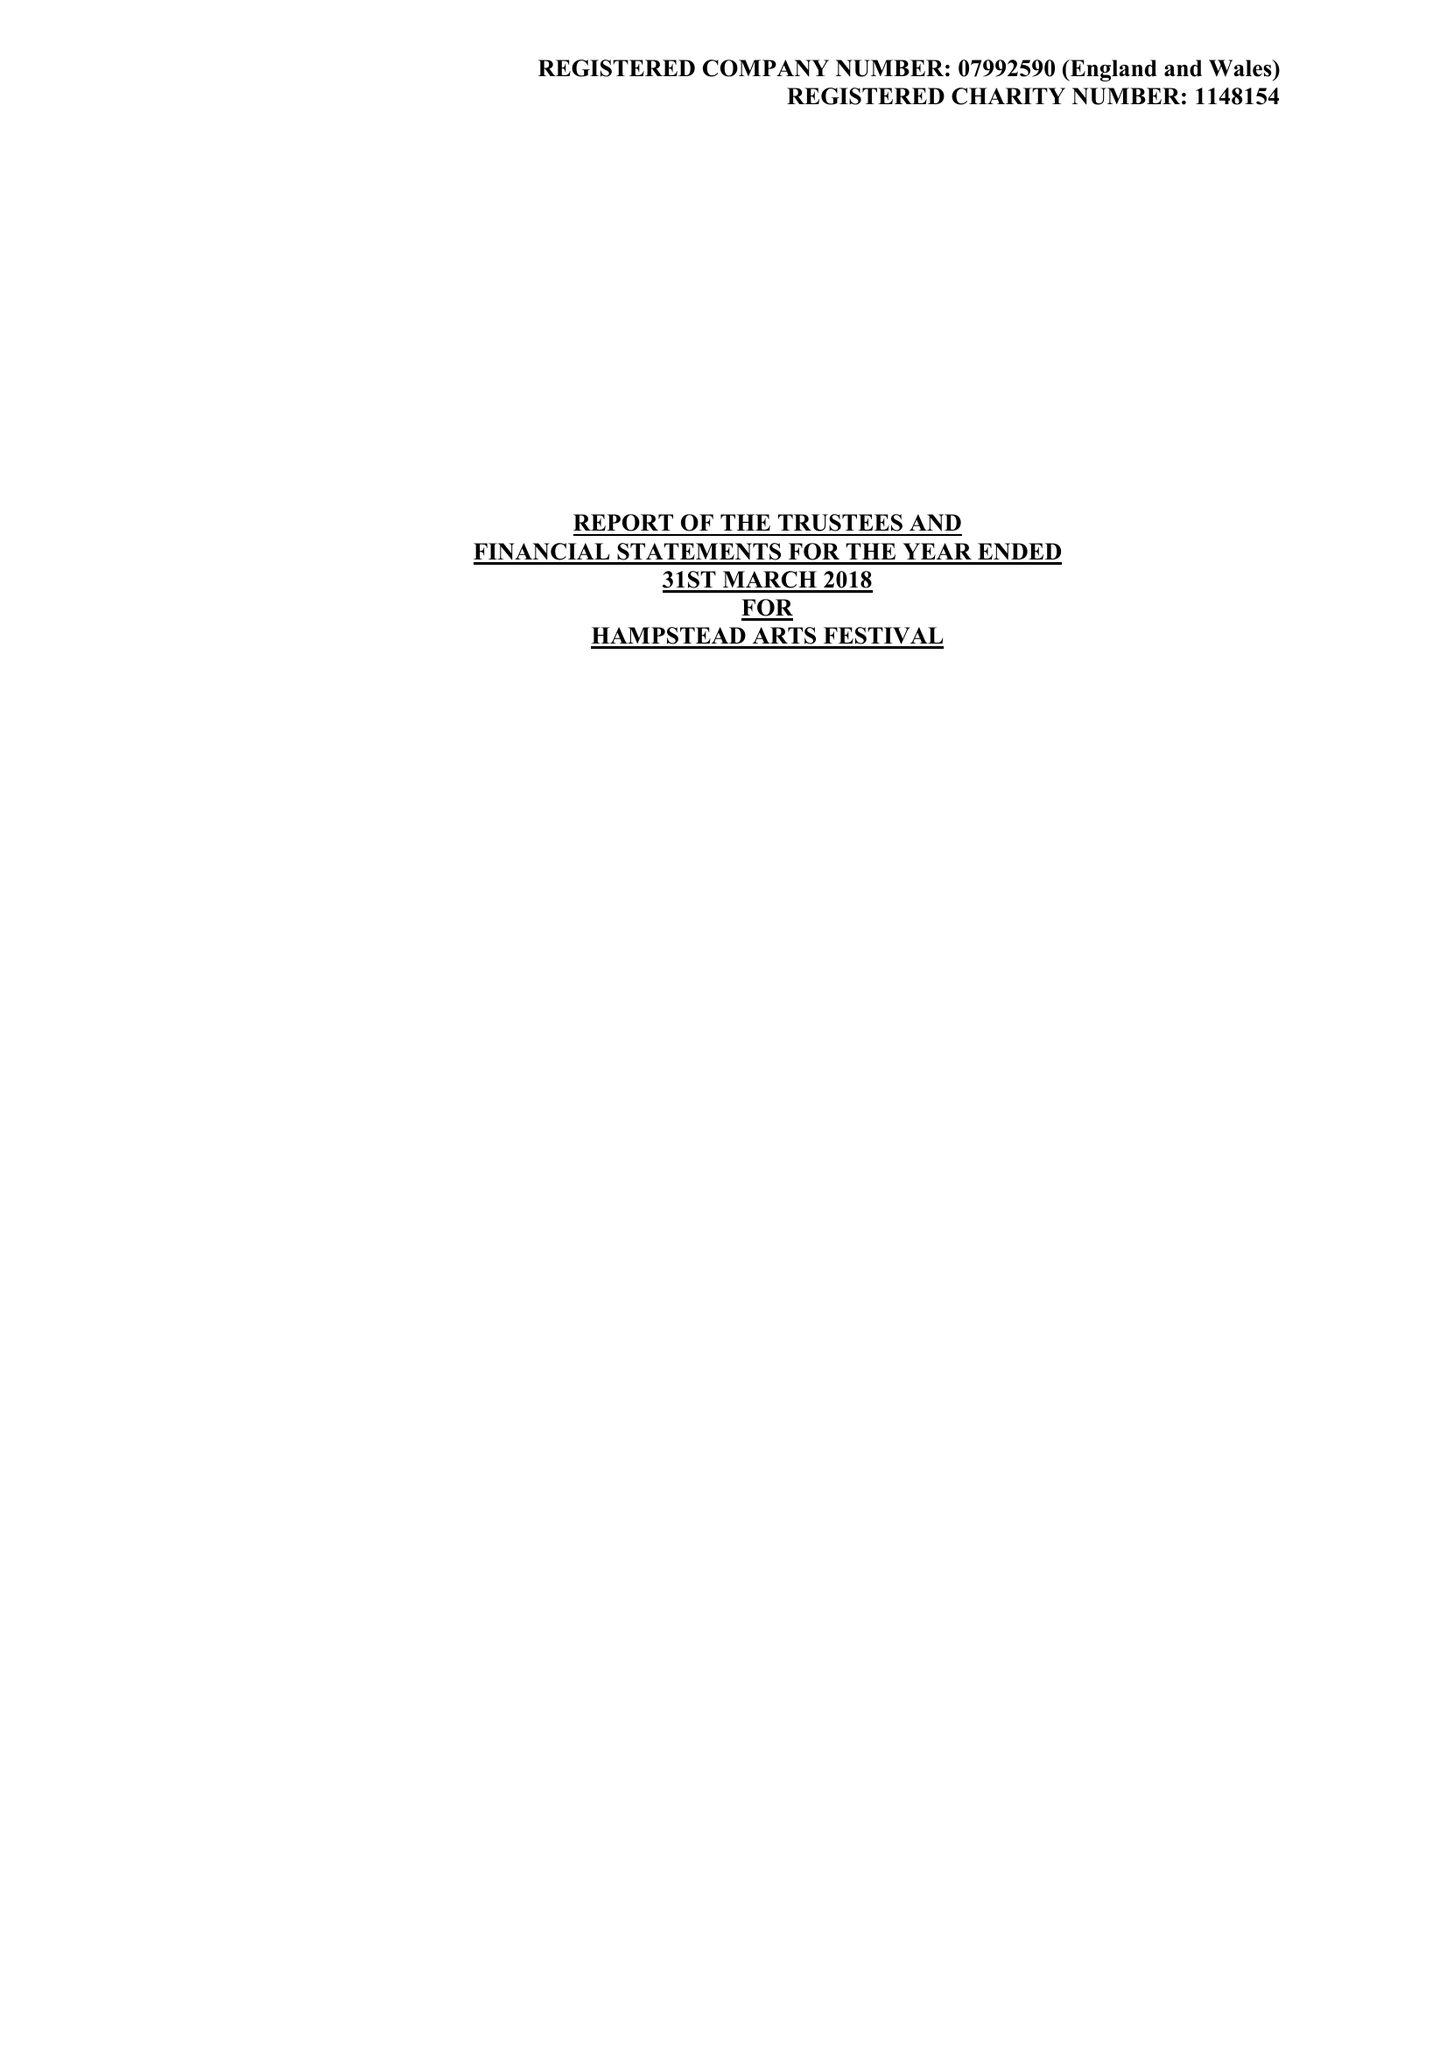What is the value for the charity_name?
Answer the question using a single word or phrase. Hampstead Arts Festival 